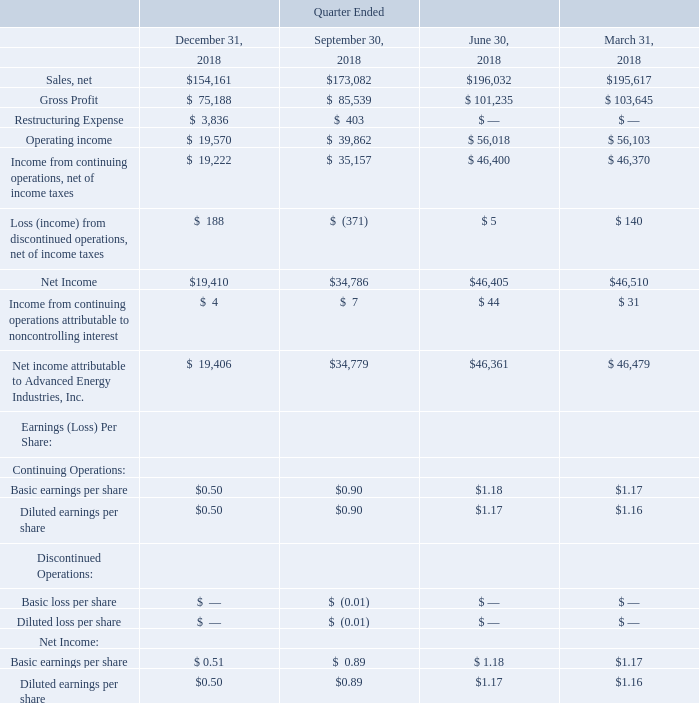ADVANCED ENERGY INDUSTRIES, INC. NOTES TO CONSOLIDATED FINANCIAL STATEMENTS – (continued) (in thousands, except per share amounts)
NOTE 23. SUPPLEMENTAL QUARTERLY FINANCIAL DATA (UNAUDITED)
The following tables present unaudited quarterly results for each of the eight quarters in the periods ended December 31, 2019 and 2018, in thousands. We believe that all necessary adjustments have been included in the amounts stated below to present fairly such quarterly information. Due to the volatility of the industries in which our customers operate, the operating results for any quarter are not necessarily indicative of results for any subsequent period.
What was the basic earnings per share of Continuing Operations  in  Quarter Ended  December? $0.50. What was the diluted earnings per share of Continuing Operations in Quarter Ended  September? $0.90. What was the net income basic earnings per share in Quarter Ended  March? $1.17. What was the change in net income between Quarter Ended  September and December?
Answer scale should be: thousand. $19,410-$34,786
Answer: -15376. What was the change in Net income attributable to Advanced Energy Industries, Inc. between Quarter Ended  June and September?
Answer scale should be: thousand. $34,779-$46,361
Answer: -11582. What was the percentage change in net sales between Quarter Ended  June and September?
Answer scale should be: percent. ($173,082-$196,032)/$196,032
Answer: -11.71. 